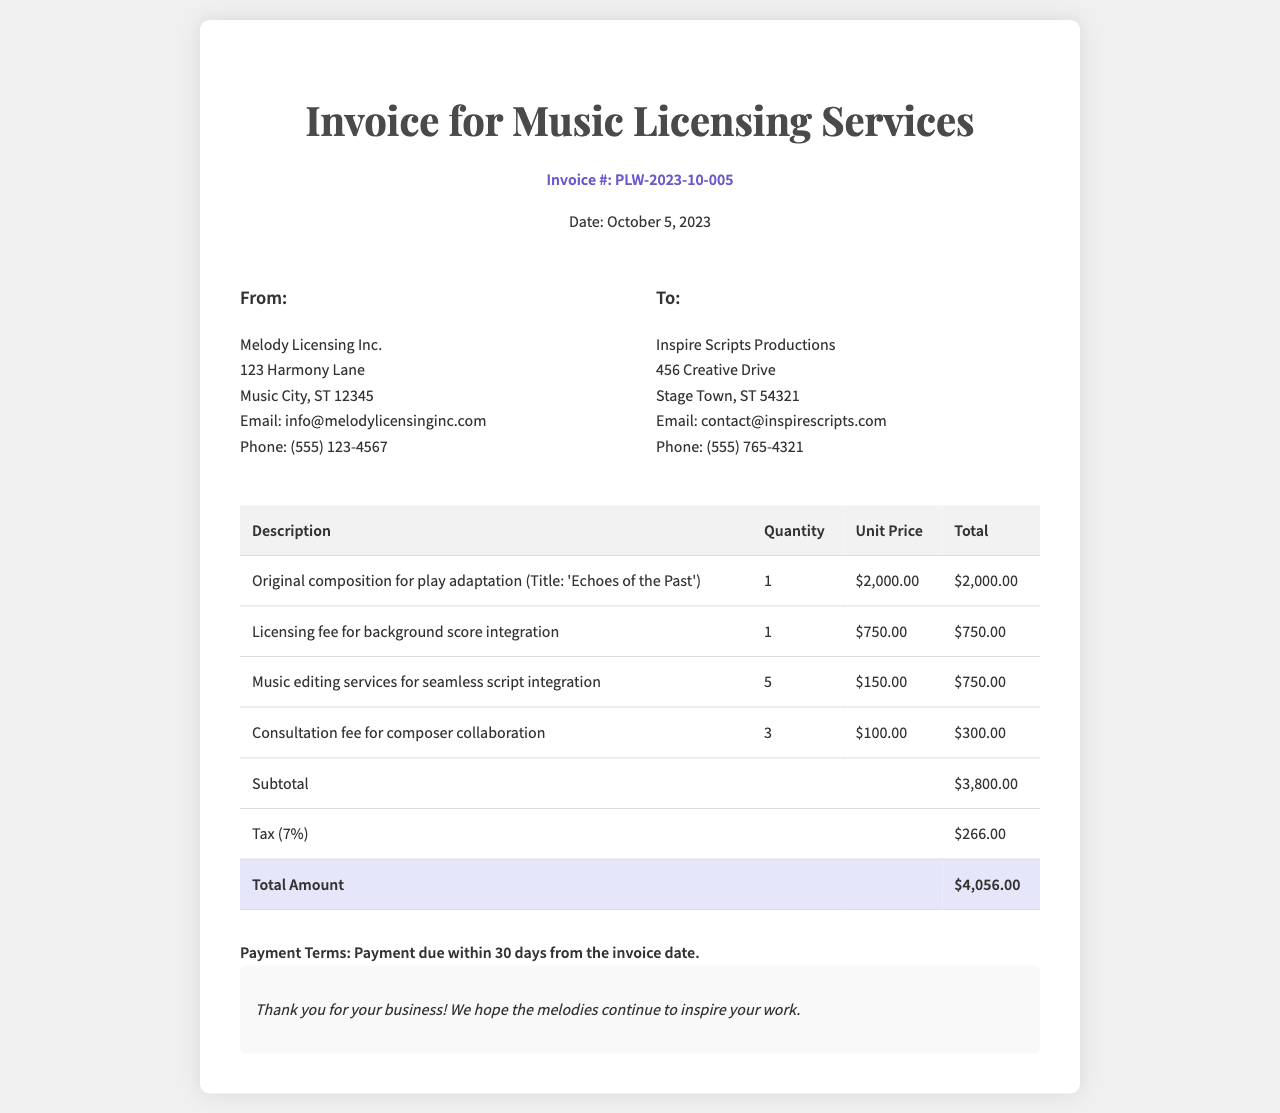What is the invoice number? The invoice number is located at the top of the document under the header section.
Answer: PLW-2023-10-005 What is the total amount due? The total amount due can be found in the total row at the bottom of the invoice table.
Answer: $4,056.00 What is the date of the invoice? The date of the invoice is listed right next to the invoice number in the header section.
Answer: October 5, 2023 How many original compositions are listed in the invoice? The invoice specifies the number of original compositions in the description of the first line item.
Answer: 1 What is the subtotal amount before tax? The subtotal is provided near the bottom of the invoice table, before the tax calculation.
Answer: $3,800.00 What is the tax rate applied in the invoice? The tax percentage is mentioned in the tax row of the invoice table.
Answer: 7% Who is the recipient of the invoice? The recipient is listed under the "To:" section in the invoice details.
Answer: Inspire Scripts Productions What is the consultation fee per session? The consultation fee is detailed in the table as the unit price for the related services.
Answer: $100.00 What payment terms are mentioned in the invoice? Payment terms can be found in the terms section towards the end of the document.
Answer: Payment due within 30 days from the invoice date 